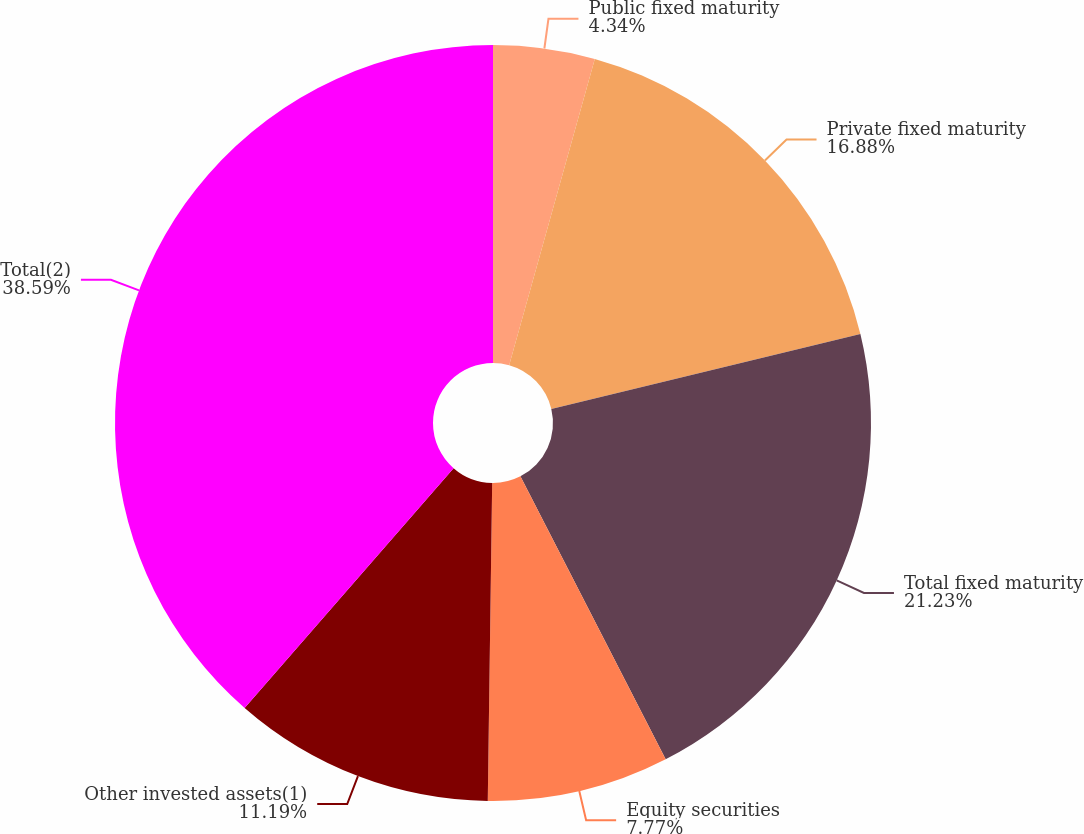<chart> <loc_0><loc_0><loc_500><loc_500><pie_chart><fcel>Public fixed maturity<fcel>Private fixed maturity<fcel>Total fixed maturity<fcel>Equity securities<fcel>Other invested assets(1)<fcel>Total(2)<nl><fcel>4.34%<fcel>16.88%<fcel>21.23%<fcel>7.77%<fcel>11.19%<fcel>38.59%<nl></chart> 